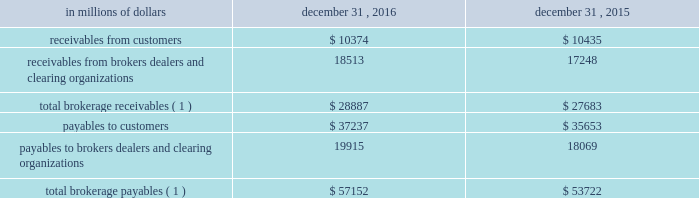12 .
Brokerage receivables and brokerage payables citi has receivables and payables for financial instruments sold to and purchased from brokers , dealers and customers , which arise in the ordinary course of business .
Citi is exposed to risk of loss from the inability of brokers , dealers or customers to pay for purchases or to deliver the financial instruments sold , in which case citi would have to sell or purchase the financial instruments at prevailing market prices .
Credit risk is reduced to the extent that an exchange or clearing organization acts as a counterparty to the transaction and replaces the broker , dealer or customer in question .
Citi seeks to protect itself from the risks associated with customer activities by requiring customers to maintain margin collateral in compliance with regulatory and internal guidelines .
Margin levels are monitored daily , and customers deposit additional collateral as required .
Where customers cannot meet collateral requirements , citi may liquidate sufficient underlying financial instruments to bring the customer into compliance with the required margin level .
Exposure to credit risk is impacted by market volatility , which may impair the ability of clients to satisfy their obligations to citi .
Credit limits are established and closely monitored for customers and for brokers and dealers engaged in forwards , futures and other transactions deemed to be credit sensitive .
Brokerage receivables and brokerage payables consisted of the following: .
Payables to brokers , dealers , and clearing organizations 19915 18069 total brokerage payables ( 1 ) $ 57152 $ 53722 ( 1 ) includes brokerage receivables and payables recorded by citi broker- dealer entities that are accounted for in accordance with the aicpa accounting guide for brokers and dealers in securities as codified in asc 940-320. .
As of december 31 , 2016 what was the ratio of receivables from brokers dealers and clearing organizations to payables to brokers dealers and clearing organizations? 
Computations: (18513 / 19915)
Answer: 0.9296. 